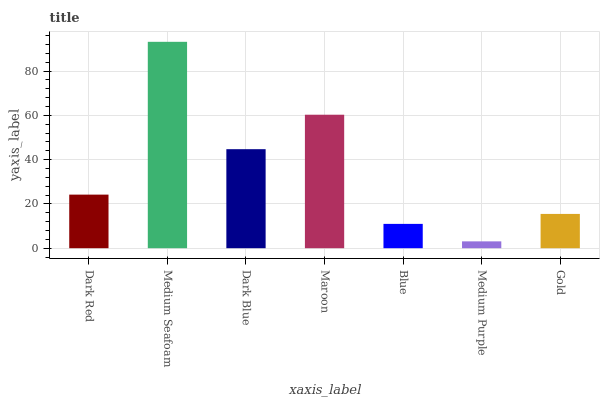Is Dark Blue the minimum?
Answer yes or no. No. Is Dark Blue the maximum?
Answer yes or no. No. Is Medium Seafoam greater than Dark Blue?
Answer yes or no. Yes. Is Dark Blue less than Medium Seafoam?
Answer yes or no. Yes. Is Dark Blue greater than Medium Seafoam?
Answer yes or no. No. Is Medium Seafoam less than Dark Blue?
Answer yes or no. No. Is Dark Red the high median?
Answer yes or no. Yes. Is Dark Red the low median?
Answer yes or no. Yes. Is Medium Purple the high median?
Answer yes or no. No. Is Blue the low median?
Answer yes or no. No. 